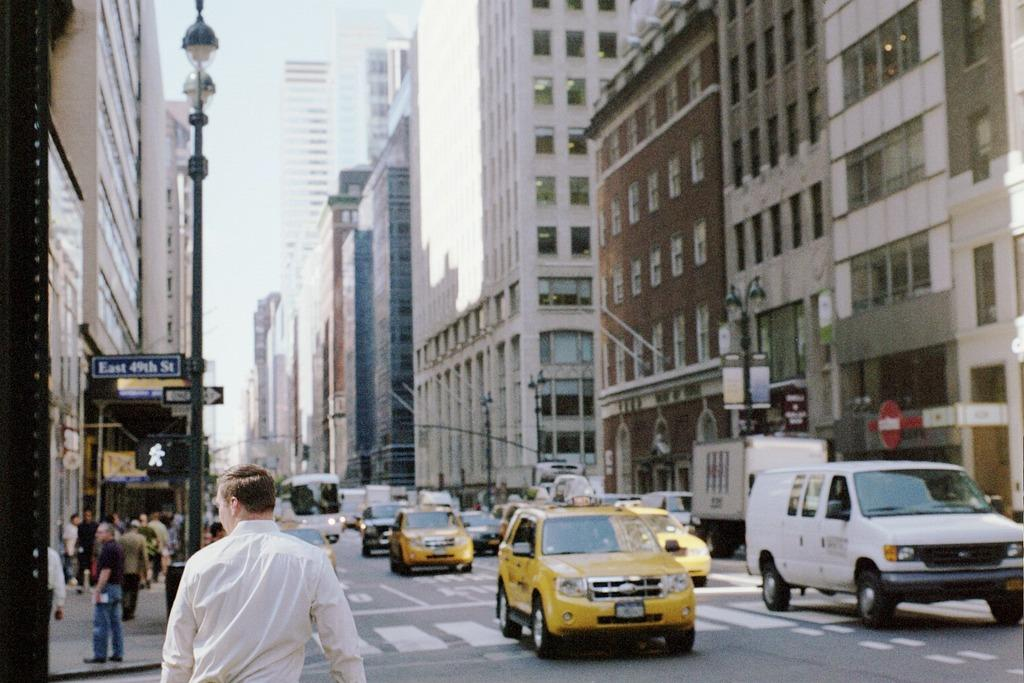<image>
Summarize the visual content of the image. Many cars approach the intersection of East 49th street. 